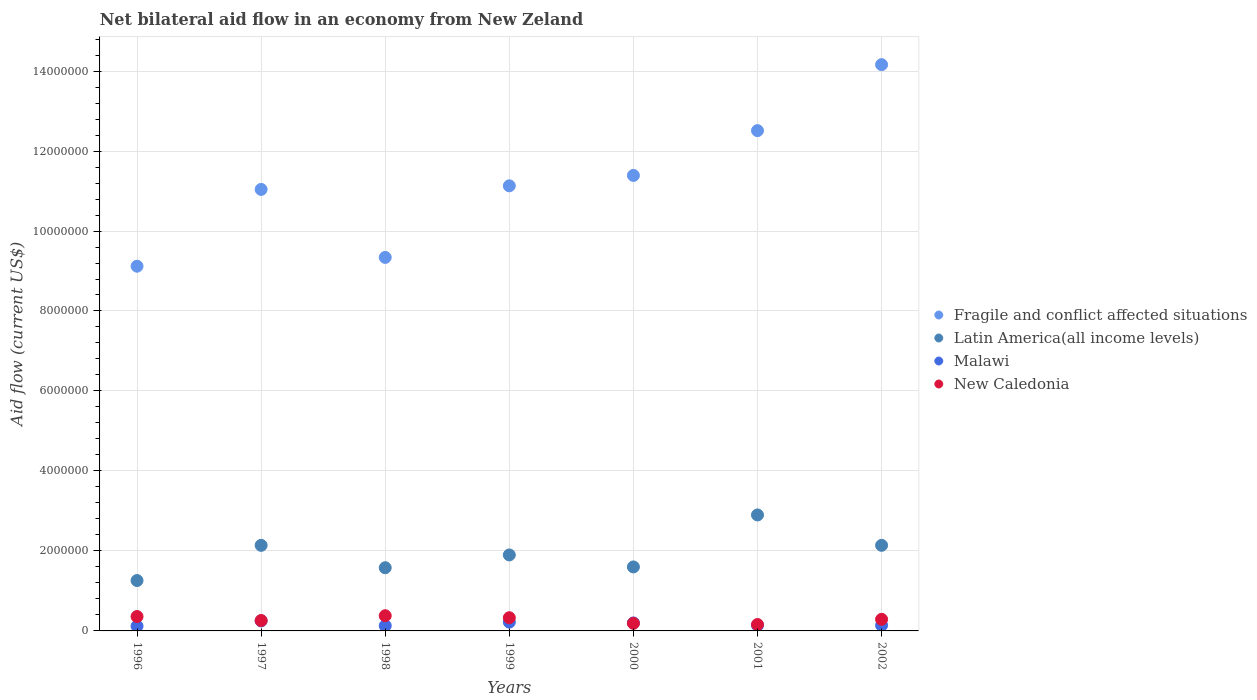What is the net bilateral aid flow in Latin America(all income levels) in 1997?
Provide a succinct answer. 2.14e+06. Across all years, what is the maximum net bilateral aid flow in Latin America(all income levels)?
Offer a terse response. 2.90e+06. What is the total net bilateral aid flow in Fragile and conflict affected situations in the graph?
Offer a terse response. 7.87e+07. What is the difference between the net bilateral aid flow in Fragile and conflict affected situations in 2000 and that in 2002?
Provide a short and direct response. -2.77e+06. What is the difference between the net bilateral aid flow in New Caledonia in 1998 and the net bilateral aid flow in Malawi in 1996?
Keep it short and to the point. 2.60e+05. What is the average net bilateral aid flow in Latin America(all income levels) per year?
Offer a terse response. 1.93e+06. In the year 2000, what is the difference between the net bilateral aid flow in Fragile and conflict affected situations and net bilateral aid flow in Latin America(all income levels)?
Offer a terse response. 9.79e+06. In how many years, is the net bilateral aid flow in New Caledonia greater than 5200000 US$?
Offer a very short reply. 0. What is the ratio of the net bilateral aid flow in Fragile and conflict affected situations in 1998 to that in 2001?
Your answer should be compact. 0.75. What is the difference between the highest and the second highest net bilateral aid flow in Latin America(all income levels)?
Your answer should be very brief. 7.60e+05. What is the difference between the highest and the lowest net bilateral aid flow in Latin America(all income levels)?
Offer a terse response. 1.64e+06. Is the sum of the net bilateral aid flow in Malawi in 1997 and 2002 greater than the maximum net bilateral aid flow in Latin America(all income levels) across all years?
Your response must be concise. No. Does the net bilateral aid flow in New Caledonia monotonically increase over the years?
Give a very brief answer. No. Is the net bilateral aid flow in New Caledonia strictly less than the net bilateral aid flow in Malawi over the years?
Your answer should be very brief. No. How many years are there in the graph?
Offer a terse response. 7. Are the values on the major ticks of Y-axis written in scientific E-notation?
Offer a very short reply. No. How are the legend labels stacked?
Your response must be concise. Vertical. What is the title of the graph?
Give a very brief answer. Net bilateral aid flow in an economy from New Zeland. Does "St. Martin (French part)" appear as one of the legend labels in the graph?
Offer a terse response. No. What is the label or title of the X-axis?
Your answer should be compact. Years. What is the label or title of the Y-axis?
Provide a short and direct response. Aid flow (current US$). What is the Aid flow (current US$) in Fragile and conflict affected situations in 1996?
Ensure brevity in your answer.  9.12e+06. What is the Aid flow (current US$) of Latin America(all income levels) in 1996?
Give a very brief answer. 1.26e+06. What is the Aid flow (current US$) of New Caledonia in 1996?
Provide a short and direct response. 3.60e+05. What is the Aid flow (current US$) of Fragile and conflict affected situations in 1997?
Make the answer very short. 1.10e+07. What is the Aid flow (current US$) in Latin America(all income levels) in 1997?
Provide a short and direct response. 2.14e+06. What is the Aid flow (current US$) of Malawi in 1997?
Offer a very short reply. 2.50e+05. What is the Aid flow (current US$) in Fragile and conflict affected situations in 1998?
Your answer should be compact. 9.34e+06. What is the Aid flow (current US$) of Latin America(all income levels) in 1998?
Ensure brevity in your answer.  1.58e+06. What is the Aid flow (current US$) in Fragile and conflict affected situations in 1999?
Offer a terse response. 1.11e+07. What is the Aid flow (current US$) of Latin America(all income levels) in 1999?
Your answer should be very brief. 1.90e+06. What is the Aid flow (current US$) in Fragile and conflict affected situations in 2000?
Your answer should be compact. 1.14e+07. What is the Aid flow (current US$) of Latin America(all income levels) in 2000?
Your response must be concise. 1.60e+06. What is the Aid flow (current US$) of Malawi in 2000?
Your answer should be compact. 2.00e+05. What is the Aid flow (current US$) in Fragile and conflict affected situations in 2001?
Give a very brief answer. 1.25e+07. What is the Aid flow (current US$) of Latin America(all income levels) in 2001?
Make the answer very short. 2.90e+06. What is the Aid flow (current US$) of Malawi in 2001?
Your response must be concise. 1.40e+05. What is the Aid flow (current US$) of New Caledonia in 2001?
Offer a very short reply. 1.60e+05. What is the Aid flow (current US$) of Fragile and conflict affected situations in 2002?
Offer a very short reply. 1.42e+07. What is the Aid flow (current US$) of Latin America(all income levels) in 2002?
Your response must be concise. 2.14e+06. What is the Aid flow (current US$) in Malawi in 2002?
Your answer should be compact. 1.40e+05. What is the Aid flow (current US$) in New Caledonia in 2002?
Ensure brevity in your answer.  2.90e+05. Across all years, what is the maximum Aid flow (current US$) of Fragile and conflict affected situations?
Make the answer very short. 1.42e+07. Across all years, what is the maximum Aid flow (current US$) of Latin America(all income levels)?
Offer a terse response. 2.90e+06. Across all years, what is the minimum Aid flow (current US$) in Fragile and conflict affected situations?
Make the answer very short. 9.12e+06. Across all years, what is the minimum Aid flow (current US$) of Latin America(all income levels)?
Your answer should be compact. 1.26e+06. Across all years, what is the minimum Aid flow (current US$) of Malawi?
Provide a succinct answer. 1.20e+05. Across all years, what is the minimum Aid flow (current US$) of New Caledonia?
Offer a terse response. 1.60e+05. What is the total Aid flow (current US$) in Fragile and conflict affected situations in the graph?
Make the answer very short. 7.87e+07. What is the total Aid flow (current US$) in Latin America(all income levels) in the graph?
Provide a short and direct response. 1.35e+07. What is the total Aid flow (current US$) of Malawi in the graph?
Provide a short and direct response. 1.20e+06. What is the total Aid flow (current US$) of New Caledonia in the graph?
Your answer should be very brief. 1.97e+06. What is the difference between the Aid flow (current US$) of Fragile and conflict affected situations in 1996 and that in 1997?
Provide a short and direct response. -1.92e+06. What is the difference between the Aid flow (current US$) in Latin America(all income levels) in 1996 and that in 1997?
Give a very brief answer. -8.80e+05. What is the difference between the Aid flow (current US$) of Malawi in 1996 and that in 1997?
Your answer should be compact. -1.30e+05. What is the difference between the Aid flow (current US$) in New Caledonia in 1996 and that in 1997?
Provide a short and direct response. 1.00e+05. What is the difference between the Aid flow (current US$) in Latin America(all income levels) in 1996 and that in 1998?
Your response must be concise. -3.20e+05. What is the difference between the Aid flow (current US$) in Malawi in 1996 and that in 1998?
Offer a very short reply. -10000. What is the difference between the Aid flow (current US$) of Fragile and conflict affected situations in 1996 and that in 1999?
Make the answer very short. -2.01e+06. What is the difference between the Aid flow (current US$) in Latin America(all income levels) in 1996 and that in 1999?
Provide a short and direct response. -6.40e+05. What is the difference between the Aid flow (current US$) in New Caledonia in 1996 and that in 1999?
Your response must be concise. 3.00e+04. What is the difference between the Aid flow (current US$) of Fragile and conflict affected situations in 1996 and that in 2000?
Keep it short and to the point. -2.27e+06. What is the difference between the Aid flow (current US$) of New Caledonia in 1996 and that in 2000?
Your answer should be very brief. 1.70e+05. What is the difference between the Aid flow (current US$) of Fragile and conflict affected situations in 1996 and that in 2001?
Make the answer very short. -3.39e+06. What is the difference between the Aid flow (current US$) of Latin America(all income levels) in 1996 and that in 2001?
Your response must be concise. -1.64e+06. What is the difference between the Aid flow (current US$) in New Caledonia in 1996 and that in 2001?
Your response must be concise. 2.00e+05. What is the difference between the Aid flow (current US$) in Fragile and conflict affected situations in 1996 and that in 2002?
Your response must be concise. -5.04e+06. What is the difference between the Aid flow (current US$) of Latin America(all income levels) in 1996 and that in 2002?
Provide a short and direct response. -8.80e+05. What is the difference between the Aid flow (current US$) in Malawi in 1996 and that in 2002?
Offer a very short reply. -2.00e+04. What is the difference between the Aid flow (current US$) of New Caledonia in 1996 and that in 2002?
Provide a short and direct response. 7.00e+04. What is the difference between the Aid flow (current US$) in Fragile and conflict affected situations in 1997 and that in 1998?
Provide a succinct answer. 1.70e+06. What is the difference between the Aid flow (current US$) in Latin America(all income levels) in 1997 and that in 1998?
Provide a short and direct response. 5.60e+05. What is the difference between the Aid flow (current US$) of Latin America(all income levels) in 1997 and that in 1999?
Keep it short and to the point. 2.40e+05. What is the difference between the Aid flow (current US$) of Malawi in 1997 and that in 1999?
Your answer should be compact. 3.00e+04. What is the difference between the Aid flow (current US$) of Fragile and conflict affected situations in 1997 and that in 2000?
Give a very brief answer. -3.50e+05. What is the difference between the Aid flow (current US$) in Latin America(all income levels) in 1997 and that in 2000?
Make the answer very short. 5.40e+05. What is the difference between the Aid flow (current US$) in Malawi in 1997 and that in 2000?
Offer a very short reply. 5.00e+04. What is the difference between the Aid flow (current US$) of New Caledonia in 1997 and that in 2000?
Make the answer very short. 7.00e+04. What is the difference between the Aid flow (current US$) in Fragile and conflict affected situations in 1997 and that in 2001?
Your answer should be very brief. -1.47e+06. What is the difference between the Aid flow (current US$) of Latin America(all income levels) in 1997 and that in 2001?
Your answer should be very brief. -7.60e+05. What is the difference between the Aid flow (current US$) in Malawi in 1997 and that in 2001?
Provide a short and direct response. 1.10e+05. What is the difference between the Aid flow (current US$) in Fragile and conflict affected situations in 1997 and that in 2002?
Your response must be concise. -3.12e+06. What is the difference between the Aid flow (current US$) of Latin America(all income levels) in 1997 and that in 2002?
Give a very brief answer. 0. What is the difference between the Aid flow (current US$) in New Caledonia in 1997 and that in 2002?
Provide a short and direct response. -3.00e+04. What is the difference between the Aid flow (current US$) in Fragile and conflict affected situations in 1998 and that in 1999?
Offer a very short reply. -1.79e+06. What is the difference between the Aid flow (current US$) of Latin America(all income levels) in 1998 and that in 1999?
Offer a terse response. -3.20e+05. What is the difference between the Aid flow (current US$) of Fragile and conflict affected situations in 1998 and that in 2000?
Make the answer very short. -2.05e+06. What is the difference between the Aid flow (current US$) of Fragile and conflict affected situations in 1998 and that in 2001?
Ensure brevity in your answer.  -3.17e+06. What is the difference between the Aid flow (current US$) of Latin America(all income levels) in 1998 and that in 2001?
Your answer should be very brief. -1.32e+06. What is the difference between the Aid flow (current US$) in Malawi in 1998 and that in 2001?
Provide a succinct answer. -10000. What is the difference between the Aid flow (current US$) in Fragile and conflict affected situations in 1998 and that in 2002?
Your response must be concise. -4.82e+06. What is the difference between the Aid flow (current US$) in Latin America(all income levels) in 1998 and that in 2002?
Offer a very short reply. -5.60e+05. What is the difference between the Aid flow (current US$) of Malawi in 1999 and that in 2000?
Ensure brevity in your answer.  2.00e+04. What is the difference between the Aid flow (current US$) in New Caledonia in 1999 and that in 2000?
Offer a terse response. 1.40e+05. What is the difference between the Aid flow (current US$) of Fragile and conflict affected situations in 1999 and that in 2001?
Your answer should be compact. -1.38e+06. What is the difference between the Aid flow (current US$) in Malawi in 1999 and that in 2001?
Your answer should be compact. 8.00e+04. What is the difference between the Aid flow (current US$) of New Caledonia in 1999 and that in 2001?
Offer a terse response. 1.70e+05. What is the difference between the Aid flow (current US$) in Fragile and conflict affected situations in 1999 and that in 2002?
Keep it short and to the point. -3.03e+06. What is the difference between the Aid flow (current US$) in Latin America(all income levels) in 1999 and that in 2002?
Your response must be concise. -2.40e+05. What is the difference between the Aid flow (current US$) in New Caledonia in 1999 and that in 2002?
Make the answer very short. 4.00e+04. What is the difference between the Aid flow (current US$) in Fragile and conflict affected situations in 2000 and that in 2001?
Make the answer very short. -1.12e+06. What is the difference between the Aid flow (current US$) in Latin America(all income levels) in 2000 and that in 2001?
Your response must be concise. -1.30e+06. What is the difference between the Aid flow (current US$) of Fragile and conflict affected situations in 2000 and that in 2002?
Ensure brevity in your answer.  -2.77e+06. What is the difference between the Aid flow (current US$) in Latin America(all income levels) in 2000 and that in 2002?
Keep it short and to the point. -5.40e+05. What is the difference between the Aid flow (current US$) of New Caledonia in 2000 and that in 2002?
Give a very brief answer. -1.00e+05. What is the difference between the Aid flow (current US$) of Fragile and conflict affected situations in 2001 and that in 2002?
Your answer should be compact. -1.65e+06. What is the difference between the Aid flow (current US$) of Latin America(all income levels) in 2001 and that in 2002?
Your answer should be compact. 7.60e+05. What is the difference between the Aid flow (current US$) of Malawi in 2001 and that in 2002?
Offer a terse response. 0. What is the difference between the Aid flow (current US$) in New Caledonia in 2001 and that in 2002?
Make the answer very short. -1.30e+05. What is the difference between the Aid flow (current US$) of Fragile and conflict affected situations in 1996 and the Aid flow (current US$) of Latin America(all income levels) in 1997?
Keep it short and to the point. 6.98e+06. What is the difference between the Aid flow (current US$) of Fragile and conflict affected situations in 1996 and the Aid flow (current US$) of Malawi in 1997?
Make the answer very short. 8.87e+06. What is the difference between the Aid flow (current US$) in Fragile and conflict affected situations in 1996 and the Aid flow (current US$) in New Caledonia in 1997?
Your answer should be compact. 8.86e+06. What is the difference between the Aid flow (current US$) in Latin America(all income levels) in 1996 and the Aid flow (current US$) in Malawi in 1997?
Your response must be concise. 1.01e+06. What is the difference between the Aid flow (current US$) in Fragile and conflict affected situations in 1996 and the Aid flow (current US$) in Latin America(all income levels) in 1998?
Your answer should be compact. 7.54e+06. What is the difference between the Aid flow (current US$) of Fragile and conflict affected situations in 1996 and the Aid flow (current US$) of Malawi in 1998?
Offer a terse response. 8.99e+06. What is the difference between the Aid flow (current US$) of Fragile and conflict affected situations in 1996 and the Aid flow (current US$) of New Caledonia in 1998?
Your answer should be very brief. 8.74e+06. What is the difference between the Aid flow (current US$) in Latin America(all income levels) in 1996 and the Aid flow (current US$) in Malawi in 1998?
Offer a terse response. 1.13e+06. What is the difference between the Aid flow (current US$) of Latin America(all income levels) in 1996 and the Aid flow (current US$) of New Caledonia in 1998?
Keep it short and to the point. 8.80e+05. What is the difference between the Aid flow (current US$) in Fragile and conflict affected situations in 1996 and the Aid flow (current US$) in Latin America(all income levels) in 1999?
Provide a succinct answer. 7.22e+06. What is the difference between the Aid flow (current US$) in Fragile and conflict affected situations in 1996 and the Aid flow (current US$) in Malawi in 1999?
Your answer should be compact. 8.90e+06. What is the difference between the Aid flow (current US$) in Fragile and conflict affected situations in 1996 and the Aid flow (current US$) in New Caledonia in 1999?
Your response must be concise. 8.79e+06. What is the difference between the Aid flow (current US$) in Latin America(all income levels) in 1996 and the Aid flow (current US$) in Malawi in 1999?
Make the answer very short. 1.04e+06. What is the difference between the Aid flow (current US$) of Latin America(all income levels) in 1996 and the Aid flow (current US$) of New Caledonia in 1999?
Your answer should be very brief. 9.30e+05. What is the difference between the Aid flow (current US$) of Fragile and conflict affected situations in 1996 and the Aid flow (current US$) of Latin America(all income levels) in 2000?
Offer a terse response. 7.52e+06. What is the difference between the Aid flow (current US$) of Fragile and conflict affected situations in 1996 and the Aid flow (current US$) of Malawi in 2000?
Make the answer very short. 8.92e+06. What is the difference between the Aid flow (current US$) in Fragile and conflict affected situations in 1996 and the Aid flow (current US$) in New Caledonia in 2000?
Keep it short and to the point. 8.93e+06. What is the difference between the Aid flow (current US$) of Latin America(all income levels) in 1996 and the Aid flow (current US$) of Malawi in 2000?
Your response must be concise. 1.06e+06. What is the difference between the Aid flow (current US$) in Latin America(all income levels) in 1996 and the Aid flow (current US$) in New Caledonia in 2000?
Ensure brevity in your answer.  1.07e+06. What is the difference between the Aid flow (current US$) of Malawi in 1996 and the Aid flow (current US$) of New Caledonia in 2000?
Your answer should be very brief. -7.00e+04. What is the difference between the Aid flow (current US$) of Fragile and conflict affected situations in 1996 and the Aid flow (current US$) of Latin America(all income levels) in 2001?
Ensure brevity in your answer.  6.22e+06. What is the difference between the Aid flow (current US$) in Fragile and conflict affected situations in 1996 and the Aid flow (current US$) in Malawi in 2001?
Provide a succinct answer. 8.98e+06. What is the difference between the Aid flow (current US$) of Fragile and conflict affected situations in 1996 and the Aid flow (current US$) of New Caledonia in 2001?
Your answer should be very brief. 8.96e+06. What is the difference between the Aid flow (current US$) of Latin America(all income levels) in 1996 and the Aid flow (current US$) of Malawi in 2001?
Give a very brief answer. 1.12e+06. What is the difference between the Aid flow (current US$) of Latin America(all income levels) in 1996 and the Aid flow (current US$) of New Caledonia in 2001?
Offer a very short reply. 1.10e+06. What is the difference between the Aid flow (current US$) of Malawi in 1996 and the Aid flow (current US$) of New Caledonia in 2001?
Provide a short and direct response. -4.00e+04. What is the difference between the Aid flow (current US$) in Fragile and conflict affected situations in 1996 and the Aid flow (current US$) in Latin America(all income levels) in 2002?
Ensure brevity in your answer.  6.98e+06. What is the difference between the Aid flow (current US$) in Fragile and conflict affected situations in 1996 and the Aid flow (current US$) in Malawi in 2002?
Your answer should be compact. 8.98e+06. What is the difference between the Aid flow (current US$) in Fragile and conflict affected situations in 1996 and the Aid flow (current US$) in New Caledonia in 2002?
Your answer should be compact. 8.83e+06. What is the difference between the Aid flow (current US$) of Latin America(all income levels) in 1996 and the Aid flow (current US$) of Malawi in 2002?
Ensure brevity in your answer.  1.12e+06. What is the difference between the Aid flow (current US$) in Latin America(all income levels) in 1996 and the Aid flow (current US$) in New Caledonia in 2002?
Offer a very short reply. 9.70e+05. What is the difference between the Aid flow (current US$) of Fragile and conflict affected situations in 1997 and the Aid flow (current US$) of Latin America(all income levels) in 1998?
Offer a terse response. 9.46e+06. What is the difference between the Aid flow (current US$) in Fragile and conflict affected situations in 1997 and the Aid flow (current US$) in Malawi in 1998?
Provide a succinct answer. 1.09e+07. What is the difference between the Aid flow (current US$) in Fragile and conflict affected situations in 1997 and the Aid flow (current US$) in New Caledonia in 1998?
Make the answer very short. 1.07e+07. What is the difference between the Aid flow (current US$) in Latin America(all income levels) in 1997 and the Aid flow (current US$) in Malawi in 1998?
Your response must be concise. 2.01e+06. What is the difference between the Aid flow (current US$) in Latin America(all income levels) in 1997 and the Aid flow (current US$) in New Caledonia in 1998?
Your answer should be very brief. 1.76e+06. What is the difference between the Aid flow (current US$) of Fragile and conflict affected situations in 1997 and the Aid flow (current US$) of Latin America(all income levels) in 1999?
Provide a succinct answer. 9.14e+06. What is the difference between the Aid flow (current US$) in Fragile and conflict affected situations in 1997 and the Aid flow (current US$) in Malawi in 1999?
Provide a short and direct response. 1.08e+07. What is the difference between the Aid flow (current US$) of Fragile and conflict affected situations in 1997 and the Aid flow (current US$) of New Caledonia in 1999?
Your answer should be compact. 1.07e+07. What is the difference between the Aid flow (current US$) of Latin America(all income levels) in 1997 and the Aid flow (current US$) of Malawi in 1999?
Ensure brevity in your answer.  1.92e+06. What is the difference between the Aid flow (current US$) in Latin America(all income levels) in 1997 and the Aid flow (current US$) in New Caledonia in 1999?
Make the answer very short. 1.81e+06. What is the difference between the Aid flow (current US$) in Fragile and conflict affected situations in 1997 and the Aid flow (current US$) in Latin America(all income levels) in 2000?
Make the answer very short. 9.44e+06. What is the difference between the Aid flow (current US$) of Fragile and conflict affected situations in 1997 and the Aid flow (current US$) of Malawi in 2000?
Your answer should be compact. 1.08e+07. What is the difference between the Aid flow (current US$) in Fragile and conflict affected situations in 1997 and the Aid flow (current US$) in New Caledonia in 2000?
Make the answer very short. 1.08e+07. What is the difference between the Aid flow (current US$) in Latin America(all income levels) in 1997 and the Aid flow (current US$) in Malawi in 2000?
Offer a very short reply. 1.94e+06. What is the difference between the Aid flow (current US$) in Latin America(all income levels) in 1997 and the Aid flow (current US$) in New Caledonia in 2000?
Offer a very short reply. 1.95e+06. What is the difference between the Aid flow (current US$) in Fragile and conflict affected situations in 1997 and the Aid flow (current US$) in Latin America(all income levels) in 2001?
Provide a succinct answer. 8.14e+06. What is the difference between the Aid flow (current US$) in Fragile and conflict affected situations in 1997 and the Aid flow (current US$) in Malawi in 2001?
Your answer should be very brief. 1.09e+07. What is the difference between the Aid flow (current US$) of Fragile and conflict affected situations in 1997 and the Aid flow (current US$) of New Caledonia in 2001?
Give a very brief answer. 1.09e+07. What is the difference between the Aid flow (current US$) of Latin America(all income levels) in 1997 and the Aid flow (current US$) of New Caledonia in 2001?
Provide a short and direct response. 1.98e+06. What is the difference between the Aid flow (current US$) in Malawi in 1997 and the Aid flow (current US$) in New Caledonia in 2001?
Your answer should be compact. 9.00e+04. What is the difference between the Aid flow (current US$) in Fragile and conflict affected situations in 1997 and the Aid flow (current US$) in Latin America(all income levels) in 2002?
Provide a succinct answer. 8.90e+06. What is the difference between the Aid flow (current US$) in Fragile and conflict affected situations in 1997 and the Aid flow (current US$) in Malawi in 2002?
Offer a terse response. 1.09e+07. What is the difference between the Aid flow (current US$) in Fragile and conflict affected situations in 1997 and the Aid flow (current US$) in New Caledonia in 2002?
Your response must be concise. 1.08e+07. What is the difference between the Aid flow (current US$) in Latin America(all income levels) in 1997 and the Aid flow (current US$) in New Caledonia in 2002?
Keep it short and to the point. 1.85e+06. What is the difference between the Aid flow (current US$) in Fragile and conflict affected situations in 1998 and the Aid flow (current US$) in Latin America(all income levels) in 1999?
Make the answer very short. 7.44e+06. What is the difference between the Aid flow (current US$) of Fragile and conflict affected situations in 1998 and the Aid flow (current US$) of Malawi in 1999?
Offer a very short reply. 9.12e+06. What is the difference between the Aid flow (current US$) of Fragile and conflict affected situations in 1998 and the Aid flow (current US$) of New Caledonia in 1999?
Your answer should be very brief. 9.01e+06. What is the difference between the Aid flow (current US$) in Latin America(all income levels) in 1998 and the Aid flow (current US$) in Malawi in 1999?
Your answer should be very brief. 1.36e+06. What is the difference between the Aid flow (current US$) in Latin America(all income levels) in 1998 and the Aid flow (current US$) in New Caledonia in 1999?
Provide a short and direct response. 1.25e+06. What is the difference between the Aid flow (current US$) in Malawi in 1998 and the Aid flow (current US$) in New Caledonia in 1999?
Provide a short and direct response. -2.00e+05. What is the difference between the Aid flow (current US$) in Fragile and conflict affected situations in 1998 and the Aid flow (current US$) in Latin America(all income levels) in 2000?
Keep it short and to the point. 7.74e+06. What is the difference between the Aid flow (current US$) of Fragile and conflict affected situations in 1998 and the Aid flow (current US$) of Malawi in 2000?
Ensure brevity in your answer.  9.14e+06. What is the difference between the Aid flow (current US$) of Fragile and conflict affected situations in 1998 and the Aid flow (current US$) of New Caledonia in 2000?
Offer a very short reply. 9.15e+06. What is the difference between the Aid flow (current US$) in Latin America(all income levels) in 1998 and the Aid flow (current US$) in Malawi in 2000?
Offer a terse response. 1.38e+06. What is the difference between the Aid flow (current US$) of Latin America(all income levels) in 1998 and the Aid flow (current US$) of New Caledonia in 2000?
Provide a short and direct response. 1.39e+06. What is the difference between the Aid flow (current US$) in Malawi in 1998 and the Aid flow (current US$) in New Caledonia in 2000?
Offer a very short reply. -6.00e+04. What is the difference between the Aid flow (current US$) in Fragile and conflict affected situations in 1998 and the Aid flow (current US$) in Latin America(all income levels) in 2001?
Offer a very short reply. 6.44e+06. What is the difference between the Aid flow (current US$) in Fragile and conflict affected situations in 1998 and the Aid flow (current US$) in Malawi in 2001?
Provide a succinct answer. 9.20e+06. What is the difference between the Aid flow (current US$) of Fragile and conflict affected situations in 1998 and the Aid flow (current US$) of New Caledonia in 2001?
Ensure brevity in your answer.  9.18e+06. What is the difference between the Aid flow (current US$) in Latin America(all income levels) in 1998 and the Aid flow (current US$) in Malawi in 2001?
Offer a terse response. 1.44e+06. What is the difference between the Aid flow (current US$) of Latin America(all income levels) in 1998 and the Aid flow (current US$) of New Caledonia in 2001?
Give a very brief answer. 1.42e+06. What is the difference between the Aid flow (current US$) in Malawi in 1998 and the Aid flow (current US$) in New Caledonia in 2001?
Ensure brevity in your answer.  -3.00e+04. What is the difference between the Aid flow (current US$) in Fragile and conflict affected situations in 1998 and the Aid flow (current US$) in Latin America(all income levels) in 2002?
Give a very brief answer. 7.20e+06. What is the difference between the Aid flow (current US$) in Fragile and conflict affected situations in 1998 and the Aid flow (current US$) in Malawi in 2002?
Give a very brief answer. 9.20e+06. What is the difference between the Aid flow (current US$) of Fragile and conflict affected situations in 1998 and the Aid flow (current US$) of New Caledonia in 2002?
Your response must be concise. 9.05e+06. What is the difference between the Aid flow (current US$) in Latin America(all income levels) in 1998 and the Aid flow (current US$) in Malawi in 2002?
Give a very brief answer. 1.44e+06. What is the difference between the Aid flow (current US$) of Latin America(all income levels) in 1998 and the Aid flow (current US$) of New Caledonia in 2002?
Keep it short and to the point. 1.29e+06. What is the difference between the Aid flow (current US$) of Malawi in 1998 and the Aid flow (current US$) of New Caledonia in 2002?
Offer a terse response. -1.60e+05. What is the difference between the Aid flow (current US$) in Fragile and conflict affected situations in 1999 and the Aid flow (current US$) in Latin America(all income levels) in 2000?
Make the answer very short. 9.53e+06. What is the difference between the Aid flow (current US$) of Fragile and conflict affected situations in 1999 and the Aid flow (current US$) of Malawi in 2000?
Your answer should be very brief. 1.09e+07. What is the difference between the Aid flow (current US$) of Fragile and conflict affected situations in 1999 and the Aid flow (current US$) of New Caledonia in 2000?
Ensure brevity in your answer.  1.09e+07. What is the difference between the Aid flow (current US$) of Latin America(all income levels) in 1999 and the Aid flow (current US$) of Malawi in 2000?
Give a very brief answer. 1.70e+06. What is the difference between the Aid flow (current US$) in Latin America(all income levels) in 1999 and the Aid flow (current US$) in New Caledonia in 2000?
Provide a succinct answer. 1.71e+06. What is the difference between the Aid flow (current US$) in Malawi in 1999 and the Aid flow (current US$) in New Caledonia in 2000?
Your response must be concise. 3.00e+04. What is the difference between the Aid flow (current US$) in Fragile and conflict affected situations in 1999 and the Aid flow (current US$) in Latin America(all income levels) in 2001?
Provide a short and direct response. 8.23e+06. What is the difference between the Aid flow (current US$) in Fragile and conflict affected situations in 1999 and the Aid flow (current US$) in Malawi in 2001?
Offer a terse response. 1.10e+07. What is the difference between the Aid flow (current US$) in Fragile and conflict affected situations in 1999 and the Aid flow (current US$) in New Caledonia in 2001?
Provide a short and direct response. 1.10e+07. What is the difference between the Aid flow (current US$) of Latin America(all income levels) in 1999 and the Aid flow (current US$) of Malawi in 2001?
Offer a very short reply. 1.76e+06. What is the difference between the Aid flow (current US$) in Latin America(all income levels) in 1999 and the Aid flow (current US$) in New Caledonia in 2001?
Offer a terse response. 1.74e+06. What is the difference between the Aid flow (current US$) of Fragile and conflict affected situations in 1999 and the Aid flow (current US$) of Latin America(all income levels) in 2002?
Your response must be concise. 8.99e+06. What is the difference between the Aid flow (current US$) in Fragile and conflict affected situations in 1999 and the Aid flow (current US$) in Malawi in 2002?
Provide a succinct answer. 1.10e+07. What is the difference between the Aid flow (current US$) in Fragile and conflict affected situations in 1999 and the Aid flow (current US$) in New Caledonia in 2002?
Your response must be concise. 1.08e+07. What is the difference between the Aid flow (current US$) in Latin America(all income levels) in 1999 and the Aid flow (current US$) in Malawi in 2002?
Offer a very short reply. 1.76e+06. What is the difference between the Aid flow (current US$) of Latin America(all income levels) in 1999 and the Aid flow (current US$) of New Caledonia in 2002?
Provide a short and direct response. 1.61e+06. What is the difference between the Aid flow (current US$) of Malawi in 1999 and the Aid flow (current US$) of New Caledonia in 2002?
Keep it short and to the point. -7.00e+04. What is the difference between the Aid flow (current US$) in Fragile and conflict affected situations in 2000 and the Aid flow (current US$) in Latin America(all income levels) in 2001?
Offer a very short reply. 8.49e+06. What is the difference between the Aid flow (current US$) of Fragile and conflict affected situations in 2000 and the Aid flow (current US$) of Malawi in 2001?
Give a very brief answer. 1.12e+07. What is the difference between the Aid flow (current US$) of Fragile and conflict affected situations in 2000 and the Aid flow (current US$) of New Caledonia in 2001?
Offer a very short reply. 1.12e+07. What is the difference between the Aid flow (current US$) of Latin America(all income levels) in 2000 and the Aid flow (current US$) of Malawi in 2001?
Offer a terse response. 1.46e+06. What is the difference between the Aid flow (current US$) in Latin America(all income levels) in 2000 and the Aid flow (current US$) in New Caledonia in 2001?
Keep it short and to the point. 1.44e+06. What is the difference between the Aid flow (current US$) in Malawi in 2000 and the Aid flow (current US$) in New Caledonia in 2001?
Ensure brevity in your answer.  4.00e+04. What is the difference between the Aid flow (current US$) in Fragile and conflict affected situations in 2000 and the Aid flow (current US$) in Latin America(all income levels) in 2002?
Your answer should be compact. 9.25e+06. What is the difference between the Aid flow (current US$) of Fragile and conflict affected situations in 2000 and the Aid flow (current US$) of Malawi in 2002?
Offer a terse response. 1.12e+07. What is the difference between the Aid flow (current US$) in Fragile and conflict affected situations in 2000 and the Aid flow (current US$) in New Caledonia in 2002?
Offer a very short reply. 1.11e+07. What is the difference between the Aid flow (current US$) in Latin America(all income levels) in 2000 and the Aid flow (current US$) in Malawi in 2002?
Ensure brevity in your answer.  1.46e+06. What is the difference between the Aid flow (current US$) in Latin America(all income levels) in 2000 and the Aid flow (current US$) in New Caledonia in 2002?
Give a very brief answer. 1.31e+06. What is the difference between the Aid flow (current US$) of Fragile and conflict affected situations in 2001 and the Aid flow (current US$) of Latin America(all income levels) in 2002?
Provide a short and direct response. 1.04e+07. What is the difference between the Aid flow (current US$) in Fragile and conflict affected situations in 2001 and the Aid flow (current US$) in Malawi in 2002?
Offer a terse response. 1.24e+07. What is the difference between the Aid flow (current US$) of Fragile and conflict affected situations in 2001 and the Aid flow (current US$) of New Caledonia in 2002?
Your response must be concise. 1.22e+07. What is the difference between the Aid flow (current US$) in Latin America(all income levels) in 2001 and the Aid flow (current US$) in Malawi in 2002?
Your answer should be very brief. 2.76e+06. What is the difference between the Aid flow (current US$) of Latin America(all income levels) in 2001 and the Aid flow (current US$) of New Caledonia in 2002?
Keep it short and to the point. 2.61e+06. What is the average Aid flow (current US$) of Fragile and conflict affected situations per year?
Your response must be concise. 1.12e+07. What is the average Aid flow (current US$) of Latin America(all income levels) per year?
Your answer should be compact. 1.93e+06. What is the average Aid flow (current US$) in Malawi per year?
Your answer should be compact. 1.71e+05. What is the average Aid flow (current US$) in New Caledonia per year?
Ensure brevity in your answer.  2.81e+05. In the year 1996, what is the difference between the Aid flow (current US$) in Fragile and conflict affected situations and Aid flow (current US$) in Latin America(all income levels)?
Offer a very short reply. 7.86e+06. In the year 1996, what is the difference between the Aid flow (current US$) of Fragile and conflict affected situations and Aid flow (current US$) of Malawi?
Your answer should be very brief. 9.00e+06. In the year 1996, what is the difference between the Aid flow (current US$) of Fragile and conflict affected situations and Aid flow (current US$) of New Caledonia?
Offer a terse response. 8.76e+06. In the year 1996, what is the difference between the Aid flow (current US$) of Latin America(all income levels) and Aid flow (current US$) of Malawi?
Give a very brief answer. 1.14e+06. In the year 1996, what is the difference between the Aid flow (current US$) in Latin America(all income levels) and Aid flow (current US$) in New Caledonia?
Provide a succinct answer. 9.00e+05. In the year 1997, what is the difference between the Aid flow (current US$) of Fragile and conflict affected situations and Aid flow (current US$) of Latin America(all income levels)?
Keep it short and to the point. 8.90e+06. In the year 1997, what is the difference between the Aid flow (current US$) in Fragile and conflict affected situations and Aid flow (current US$) in Malawi?
Make the answer very short. 1.08e+07. In the year 1997, what is the difference between the Aid flow (current US$) of Fragile and conflict affected situations and Aid flow (current US$) of New Caledonia?
Your answer should be compact. 1.08e+07. In the year 1997, what is the difference between the Aid flow (current US$) in Latin America(all income levels) and Aid flow (current US$) in Malawi?
Your answer should be very brief. 1.89e+06. In the year 1997, what is the difference between the Aid flow (current US$) of Latin America(all income levels) and Aid flow (current US$) of New Caledonia?
Your answer should be very brief. 1.88e+06. In the year 1998, what is the difference between the Aid flow (current US$) of Fragile and conflict affected situations and Aid flow (current US$) of Latin America(all income levels)?
Provide a short and direct response. 7.76e+06. In the year 1998, what is the difference between the Aid flow (current US$) of Fragile and conflict affected situations and Aid flow (current US$) of Malawi?
Make the answer very short. 9.21e+06. In the year 1998, what is the difference between the Aid flow (current US$) of Fragile and conflict affected situations and Aid flow (current US$) of New Caledonia?
Offer a terse response. 8.96e+06. In the year 1998, what is the difference between the Aid flow (current US$) of Latin America(all income levels) and Aid flow (current US$) of Malawi?
Your answer should be compact. 1.45e+06. In the year 1998, what is the difference between the Aid flow (current US$) in Latin America(all income levels) and Aid flow (current US$) in New Caledonia?
Your answer should be very brief. 1.20e+06. In the year 1998, what is the difference between the Aid flow (current US$) of Malawi and Aid flow (current US$) of New Caledonia?
Ensure brevity in your answer.  -2.50e+05. In the year 1999, what is the difference between the Aid flow (current US$) of Fragile and conflict affected situations and Aid flow (current US$) of Latin America(all income levels)?
Keep it short and to the point. 9.23e+06. In the year 1999, what is the difference between the Aid flow (current US$) of Fragile and conflict affected situations and Aid flow (current US$) of Malawi?
Your answer should be compact. 1.09e+07. In the year 1999, what is the difference between the Aid flow (current US$) in Fragile and conflict affected situations and Aid flow (current US$) in New Caledonia?
Provide a succinct answer. 1.08e+07. In the year 1999, what is the difference between the Aid flow (current US$) in Latin America(all income levels) and Aid flow (current US$) in Malawi?
Provide a succinct answer. 1.68e+06. In the year 1999, what is the difference between the Aid flow (current US$) of Latin America(all income levels) and Aid flow (current US$) of New Caledonia?
Your answer should be compact. 1.57e+06. In the year 1999, what is the difference between the Aid flow (current US$) in Malawi and Aid flow (current US$) in New Caledonia?
Offer a very short reply. -1.10e+05. In the year 2000, what is the difference between the Aid flow (current US$) of Fragile and conflict affected situations and Aid flow (current US$) of Latin America(all income levels)?
Give a very brief answer. 9.79e+06. In the year 2000, what is the difference between the Aid flow (current US$) of Fragile and conflict affected situations and Aid flow (current US$) of Malawi?
Give a very brief answer. 1.12e+07. In the year 2000, what is the difference between the Aid flow (current US$) of Fragile and conflict affected situations and Aid flow (current US$) of New Caledonia?
Provide a succinct answer. 1.12e+07. In the year 2000, what is the difference between the Aid flow (current US$) in Latin America(all income levels) and Aid flow (current US$) in Malawi?
Ensure brevity in your answer.  1.40e+06. In the year 2000, what is the difference between the Aid flow (current US$) in Latin America(all income levels) and Aid flow (current US$) in New Caledonia?
Provide a short and direct response. 1.41e+06. In the year 2001, what is the difference between the Aid flow (current US$) of Fragile and conflict affected situations and Aid flow (current US$) of Latin America(all income levels)?
Provide a succinct answer. 9.61e+06. In the year 2001, what is the difference between the Aid flow (current US$) in Fragile and conflict affected situations and Aid flow (current US$) in Malawi?
Your answer should be very brief. 1.24e+07. In the year 2001, what is the difference between the Aid flow (current US$) of Fragile and conflict affected situations and Aid flow (current US$) of New Caledonia?
Your answer should be compact. 1.24e+07. In the year 2001, what is the difference between the Aid flow (current US$) in Latin America(all income levels) and Aid flow (current US$) in Malawi?
Offer a terse response. 2.76e+06. In the year 2001, what is the difference between the Aid flow (current US$) in Latin America(all income levels) and Aid flow (current US$) in New Caledonia?
Your response must be concise. 2.74e+06. In the year 2001, what is the difference between the Aid flow (current US$) of Malawi and Aid flow (current US$) of New Caledonia?
Your response must be concise. -2.00e+04. In the year 2002, what is the difference between the Aid flow (current US$) in Fragile and conflict affected situations and Aid flow (current US$) in Latin America(all income levels)?
Ensure brevity in your answer.  1.20e+07. In the year 2002, what is the difference between the Aid flow (current US$) in Fragile and conflict affected situations and Aid flow (current US$) in Malawi?
Give a very brief answer. 1.40e+07. In the year 2002, what is the difference between the Aid flow (current US$) in Fragile and conflict affected situations and Aid flow (current US$) in New Caledonia?
Provide a succinct answer. 1.39e+07. In the year 2002, what is the difference between the Aid flow (current US$) in Latin America(all income levels) and Aid flow (current US$) in Malawi?
Your response must be concise. 2.00e+06. In the year 2002, what is the difference between the Aid flow (current US$) in Latin America(all income levels) and Aid flow (current US$) in New Caledonia?
Make the answer very short. 1.85e+06. In the year 2002, what is the difference between the Aid flow (current US$) in Malawi and Aid flow (current US$) in New Caledonia?
Your answer should be very brief. -1.50e+05. What is the ratio of the Aid flow (current US$) in Fragile and conflict affected situations in 1996 to that in 1997?
Ensure brevity in your answer.  0.83. What is the ratio of the Aid flow (current US$) in Latin America(all income levels) in 1996 to that in 1997?
Ensure brevity in your answer.  0.59. What is the ratio of the Aid flow (current US$) in Malawi in 1996 to that in 1997?
Ensure brevity in your answer.  0.48. What is the ratio of the Aid flow (current US$) in New Caledonia in 1996 to that in 1997?
Offer a terse response. 1.38. What is the ratio of the Aid flow (current US$) of Fragile and conflict affected situations in 1996 to that in 1998?
Ensure brevity in your answer.  0.98. What is the ratio of the Aid flow (current US$) of Latin America(all income levels) in 1996 to that in 1998?
Provide a short and direct response. 0.8. What is the ratio of the Aid flow (current US$) of Malawi in 1996 to that in 1998?
Keep it short and to the point. 0.92. What is the ratio of the Aid flow (current US$) of Fragile and conflict affected situations in 1996 to that in 1999?
Ensure brevity in your answer.  0.82. What is the ratio of the Aid flow (current US$) of Latin America(all income levels) in 1996 to that in 1999?
Ensure brevity in your answer.  0.66. What is the ratio of the Aid flow (current US$) of Malawi in 1996 to that in 1999?
Ensure brevity in your answer.  0.55. What is the ratio of the Aid flow (current US$) of Fragile and conflict affected situations in 1996 to that in 2000?
Provide a short and direct response. 0.8. What is the ratio of the Aid flow (current US$) in Latin America(all income levels) in 1996 to that in 2000?
Give a very brief answer. 0.79. What is the ratio of the Aid flow (current US$) of Malawi in 1996 to that in 2000?
Give a very brief answer. 0.6. What is the ratio of the Aid flow (current US$) in New Caledonia in 1996 to that in 2000?
Provide a succinct answer. 1.89. What is the ratio of the Aid flow (current US$) in Fragile and conflict affected situations in 1996 to that in 2001?
Your answer should be compact. 0.73. What is the ratio of the Aid flow (current US$) of Latin America(all income levels) in 1996 to that in 2001?
Keep it short and to the point. 0.43. What is the ratio of the Aid flow (current US$) in Malawi in 1996 to that in 2001?
Give a very brief answer. 0.86. What is the ratio of the Aid flow (current US$) in New Caledonia in 1996 to that in 2001?
Give a very brief answer. 2.25. What is the ratio of the Aid flow (current US$) of Fragile and conflict affected situations in 1996 to that in 2002?
Provide a succinct answer. 0.64. What is the ratio of the Aid flow (current US$) of Latin America(all income levels) in 1996 to that in 2002?
Your answer should be very brief. 0.59. What is the ratio of the Aid flow (current US$) in New Caledonia in 1996 to that in 2002?
Provide a succinct answer. 1.24. What is the ratio of the Aid flow (current US$) of Fragile and conflict affected situations in 1997 to that in 1998?
Provide a short and direct response. 1.18. What is the ratio of the Aid flow (current US$) of Latin America(all income levels) in 1997 to that in 1998?
Offer a very short reply. 1.35. What is the ratio of the Aid flow (current US$) in Malawi in 1997 to that in 1998?
Make the answer very short. 1.92. What is the ratio of the Aid flow (current US$) of New Caledonia in 1997 to that in 1998?
Provide a succinct answer. 0.68. What is the ratio of the Aid flow (current US$) in Latin America(all income levels) in 1997 to that in 1999?
Make the answer very short. 1.13. What is the ratio of the Aid flow (current US$) of Malawi in 1997 to that in 1999?
Provide a succinct answer. 1.14. What is the ratio of the Aid flow (current US$) of New Caledonia in 1997 to that in 1999?
Offer a terse response. 0.79. What is the ratio of the Aid flow (current US$) of Fragile and conflict affected situations in 1997 to that in 2000?
Provide a succinct answer. 0.97. What is the ratio of the Aid flow (current US$) of Latin America(all income levels) in 1997 to that in 2000?
Provide a short and direct response. 1.34. What is the ratio of the Aid flow (current US$) in New Caledonia in 1997 to that in 2000?
Ensure brevity in your answer.  1.37. What is the ratio of the Aid flow (current US$) in Fragile and conflict affected situations in 1997 to that in 2001?
Give a very brief answer. 0.88. What is the ratio of the Aid flow (current US$) in Latin America(all income levels) in 1997 to that in 2001?
Offer a very short reply. 0.74. What is the ratio of the Aid flow (current US$) in Malawi in 1997 to that in 2001?
Ensure brevity in your answer.  1.79. What is the ratio of the Aid flow (current US$) of New Caledonia in 1997 to that in 2001?
Make the answer very short. 1.62. What is the ratio of the Aid flow (current US$) in Fragile and conflict affected situations in 1997 to that in 2002?
Offer a terse response. 0.78. What is the ratio of the Aid flow (current US$) in Latin America(all income levels) in 1997 to that in 2002?
Provide a short and direct response. 1. What is the ratio of the Aid flow (current US$) in Malawi in 1997 to that in 2002?
Your response must be concise. 1.79. What is the ratio of the Aid flow (current US$) of New Caledonia in 1997 to that in 2002?
Provide a short and direct response. 0.9. What is the ratio of the Aid flow (current US$) in Fragile and conflict affected situations in 1998 to that in 1999?
Provide a succinct answer. 0.84. What is the ratio of the Aid flow (current US$) of Latin America(all income levels) in 1998 to that in 1999?
Give a very brief answer. 0.83. What is the ratio of the Aid flow (current US$) of Malawi in 1998 to that in 1999?
Offer a very short reply. 0.59. What is the ratio of the Aid flow (current US$) in New Caledonia in 1998 to that in 1999?
Give a very brief answer. 1.15. What is the ratio of the Aid flow (current US$) in Fragile and conflict affected situations in 1998 to that in 2000?
Your response must be concise. 0.82. What is the ratio of the Aid flow (current US$) in Latin America(all income levels) in 1998 to that in 2000?
Keep it short and to the point. 0.99. What is the ratio of the Aid flow (current US$) in Malawi in 1998 to that in 2000?
Make the answer very short. 0.65. What is the ratio of the Aid flow (current US$) of New Caledonia in 1998 to that in 2000?
Your answer should be compact. 2. What is the ratio of the Aid flow (current US$) in Fragile and conflict affected situations in 1998 to that in 2001?
Provide a succinct answer. 0.75. What is the ratio of the Aid flow (current US$) of Latin America(all income levels) in 1998 to that in 2001?
Ensure brevity in your answer.  0.54. What is the ratio of the Aid flow (current US$) of New Caledonia in 1998 to that in 2001?
Offer a terse response. 2.38. What is the ratio of the Aid flow (current US$) of Fragile and conflict affected situations in 1998 to that in 2002?
Give a very brief answer. 0.66. What is the ratio of the Aid flow (current US$) in Latin America(all income levels) in 1998 to that in 2002?
Ensure brevity in your answer.  0.74. What is the ratio of the Aid flow (current US$) of Malawi in 1998 to that in 2002?
Offer a terse response. 0.93. What is the ratio of the Aid flow (current US$) in New Caledonia in 1998 to that in 2002?
Your answer should be very brief. 1.31. What is the ratio of the Aid flow (current US$) of Fragile and conflict affected situations in 1999 to that in 2000?
Ensure brevity in your answer.  0.98. What is the ratio of the Aid flow (current US$) in Latin America(all income levels) in 1999 to that in 2000?
Your answer should be very brief. 1.19. What is the ratio of the Aid flow (current US$) of Malawi in 1999 to that in 2000?
Offer a very short reply. 1.1. What is the ratio of the Aid flow (current US$) in New Caledonia in 1999 to that in 2000?
Make the answer very short. 1.74. What is the ratio of the Aid flow (current US$) in Fragile and conflict affected situations in 1999 to that in 2001?
Your answer should be very brief. 0.89. What is the ratio of the Aid flow (current US$) of Latin America(all income levels) in 1999 to that in 2001?
Offer a very short reply. 0.66. What is the ratio of the Aid flow (current US$) of Malawi in 1999 to that in 2001?
Ensure brevity in your answer.  1.57. What is the ratio of the Aid flow (current US$) of New Caledonia in 1999 to that in 2001?
Offer a terse response. 2.06. What is the ratio of the Aid flow (current US$) of Fragile and conflict affected situations in 1999 to that in 2002?
Provide a short and direct response. 0.79. What is the ratio of the Aid flow (current US$) in Latin America(all income levels) in 1999 to that in 2002?
Offer a very short reply. 0.89. What is the ratio of the Aid flow (current US$) of Malawi in 1999 to that in 2002?
Provide a short and direct response. 1.57. What is the ratio of the Aid flow (current US$) in New Caledonia in 1999 to that in 2002?
Keep it short and to the point. 1.14. What is the ratio of the Aid flow (current US$) of Fragile and conflict affected situations in 2000 to that in 2001?
Give a very brief answer. 0.91. What is the ratio of the Aid flow (current US$) of Latin America(all income levels) in 2000 to that in 2001?
Provide a succinct answer. 0.55. What is the ratio of the Aid flow (current US$) in Malawi in 2000 to that in 2001?
Your answer should be very brief. 1.43. What is the ratio of the Aid flow (current US$) in New Caledonia in 2000 to that in 2001?
Provide a succinct answer. 1.19. What is the ratio of the Aid flow (current US$) in Fragile and conflict affected situations in 2000 to that in 2002?
Give a very brief answer. 0.8. What is the ratio of the Aid flow (current US$) in Latin America(all income levels) in 2000 to that in 2002?
Ensure brevity in your answer.  0.75. What is the ratio of the Aid flow (current US$) in Malawi in 2000 to that in 2002?
Keep it short and to the point. 1.43. What is the ratio of the Aid flow (current US$) of New Caledonia in 2000 to that in 2002?
Provide a short and direct response. 0.66. What is the ratio of the Aid flow (current US$) of Fragile and conflict affected situations in 2001 to that in 2002?
Provide a short and direct response. 0.88. What is the ratio of the Aid flow (current US$) in Latin America(all income levels) in 2001 to that in 2002?
Your answer should be very brief. 1.36. What is the ratio of the Aid flow (current US$) in New Caledonia in 2001 to that in 2002?
Your response must be concise. 0.55. What is the difference between the highest and the second highest Aid flow (current US$) of Fragile and conflict affected situations?
Offer a terse response. 1.65e+06. What is the difference between the highest and the second highest Aid flow (current US$) in Latin America(all income levels)?
Your answer should be compact. 7.60e+05. What is the difference between the highest and the second highest Aid flow (current US$) of New Caledonia?
Keep it short and to the point. 2.00e+04. What is the difference between the highest and the lowest Aid flow (current US$) of Fragile and conflict affected situations?
Your response must be concise. 5.04e+06. What is the difference between the highest and the lowest Aid flow (current US$) in Latin America(all income levels)?
Keep it short and to the point. 1.64e+06. 